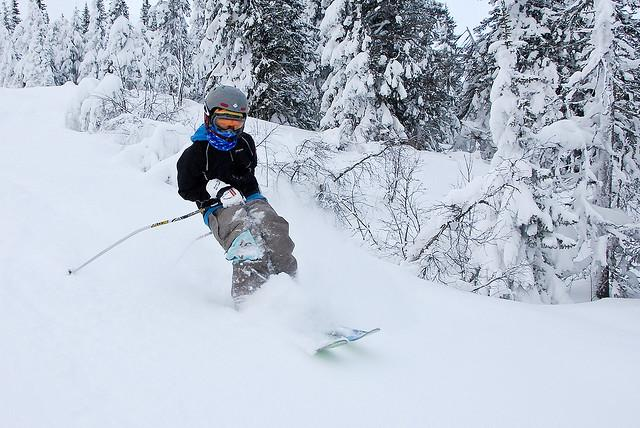Where might this child be located?

Choices:
A) texas
B) california
C) florida
D) colorado colorado 